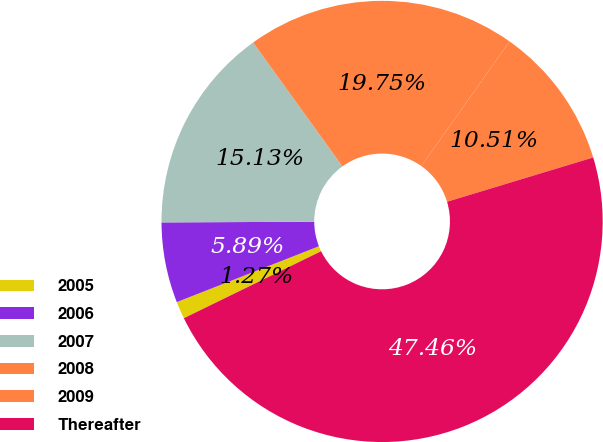Convert chart to OTSL. <chart><loc_0><loc_0><loc_500><loc_500><pie_chart><fcel>2005<fcel>2006<fcel>2007<fcel>2008<fcel>2009<fcel>Thereafter<nl><fcel>1.27%<fcel>5.89%<fcel>15.13%<fcel>19.75%<fcel>10.51%<fcel>47.46%<nl></chart> 